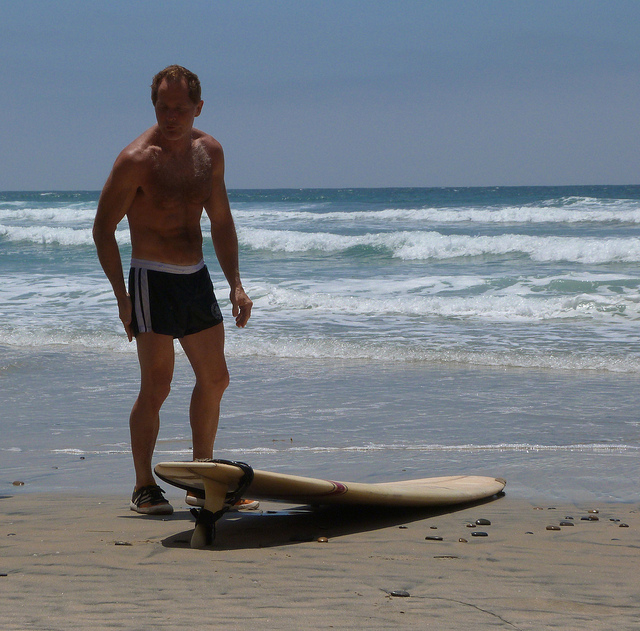Are there any other significant details or objects in the background? In the background, the sea with its rolling waves is the most prominent feature beyond the man and the surfboard. The horizon line is visible, but there do not appear to be any other significant objects or details that stand out in the scene. 